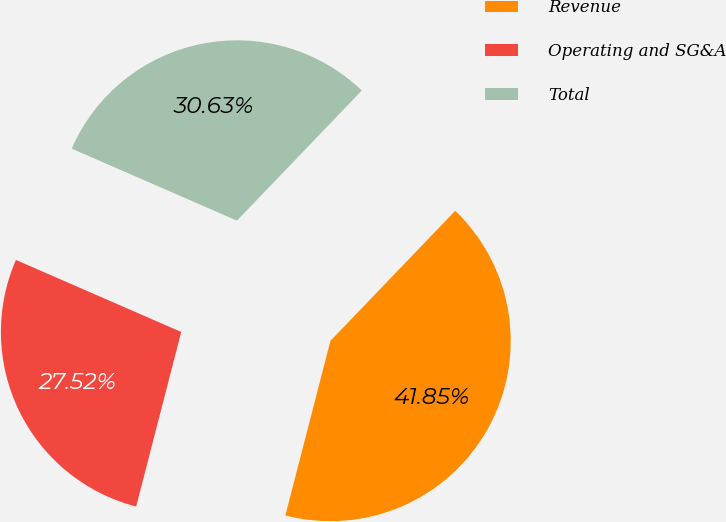Convert chart to OTSL. <chart><loc_0><loc_0><loc_500><loc_500><pie_chart><fcel>Revenue<fcel>Operating and SG&A<fcel>Total<nl><fcel>41.85%<fcel>27.52%<fcel>30.63%<nl></chart> 